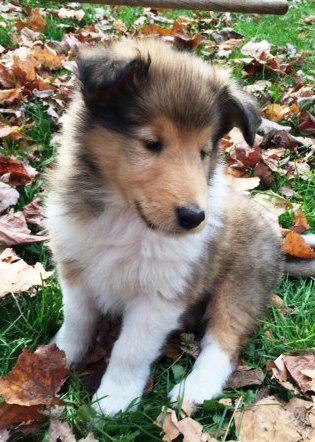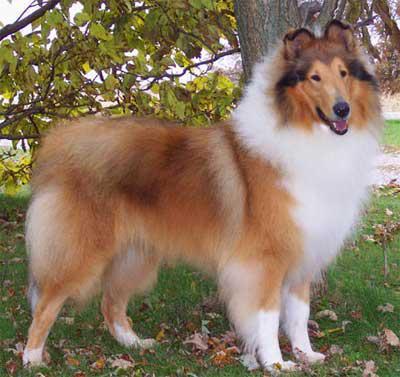The first image is the image on the left, the second image is the image on the right. Analyze the images presented: Is the assertion "An image shows a young pup sitting on a cut stump." valid? Answer yes or no. No. 